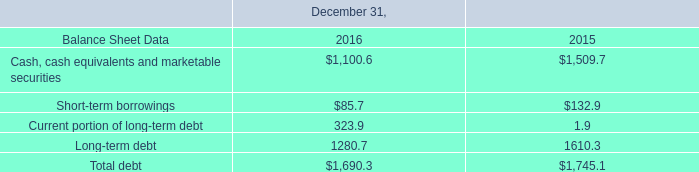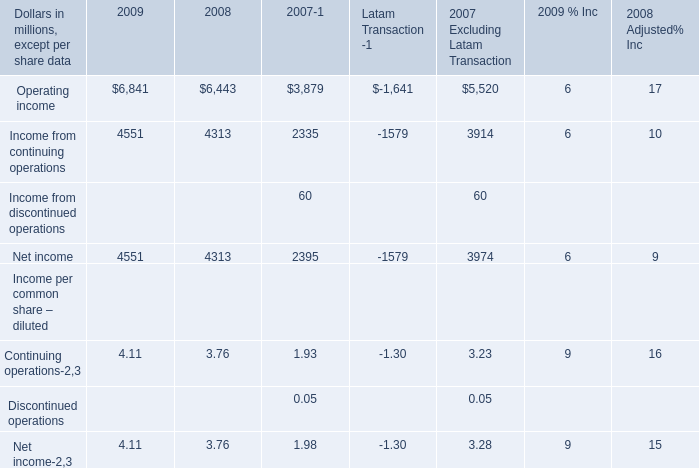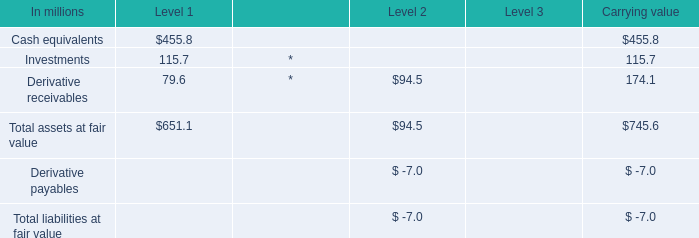What's the sum of Cash, cash equivalents and marketable securities of December 31, 2016, Operating income of 2007 Excluding Latam Transaction, and Net income of 2007 ? 
Computations: ((1100.6 + 5520.0) + 2395.0)
Answer: 9015.6. 